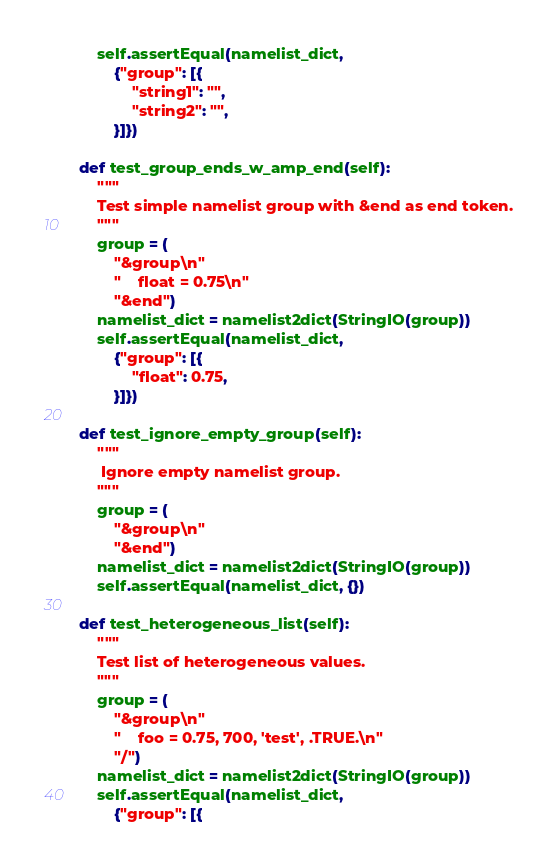<code> <loc_0><loc_0><loc_500><loc_500><_Python_>        self.assertEqual(namelist_dict,
            {"group": [{
                "string1": "",
                "string2": "",
            }]})

    def test_group_ends_w_amp_end(self):
        """
        Test simple namelist group with &end as end token.
        """
        group = (
            "&group\n"
            "    float = 0.75\n"
            "&end")
        namelist_dict = namelist2dict(StringIO(group))
        self.assertEqual(namelist_dict,
            {"group": [{
                "float": 0.75,
            }]})

    def test_ignore_empty_group(self):
        """
         Ignore empty namelist group.
        """
        group = (
            "&group\n"
            "&end")
        namelist_dict = namelist2dict(StringIO(group))
        self.assertEqual(namelist_dict, {})

    def test_heterogeneous_list(self):
        """
        Test list of heterogeneous values.
        """
        group = (
            "&group\n"
            "    foo = 0.75, 700, 'test', .TRUE.\n"
            "/")
        namelist_dict = namelist2dict(StringIO(group))
        self.assertEqual(namelist_dict,
            {"group": [{</code> 